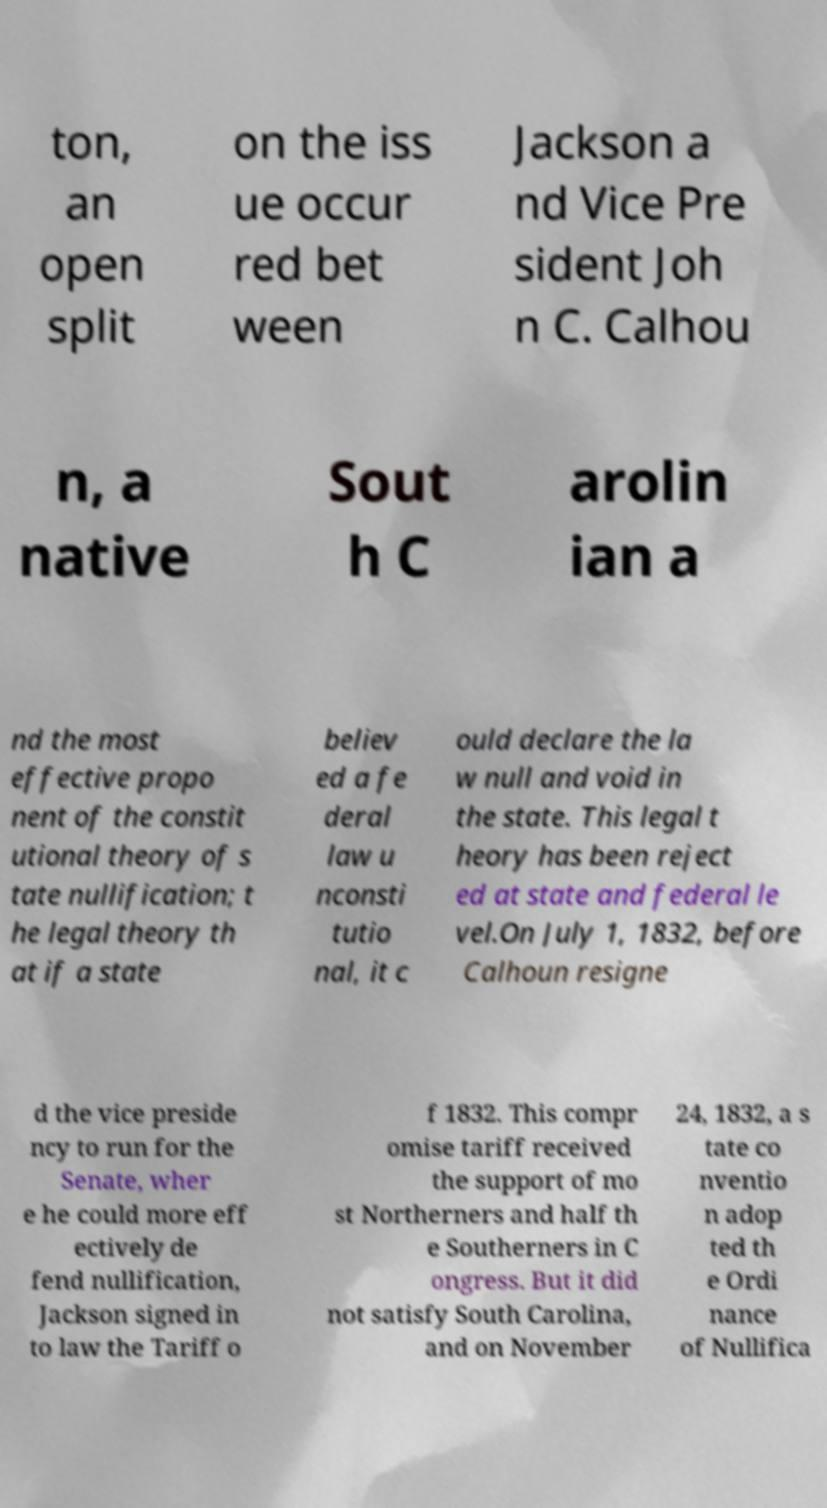Please read and relay the text visible in this image. What does it say? ton, an open split on the iss ue occur red bet ween Jackson a nd Vice Pre sident Joh n C. Calhou n, a native Sout h C arolin ian a nd the most effective propo nent of the constit utional theory of s tate nullification; t he legal theory th at if a state believ ed a fe deral law u nconsti tutio nal, it c ould declare the la w null and void in the state. This legal t heory has been reject ed at state and federal le vel.On July 1, 1832, before Calhoun resigne d the vice preside ncy to run for the Senate, wher e he could more eff ectively de fend nullification, Jackson signed in to law the Tariff o f 1832. This compr omise tariff received the support of mo st Northerners and half th e Southerners in C ongress. But it did not satisfy South Carolina, and on November 24, 1832, a s tate co nventio n adop ted th e Ordi nance of Nullifica 